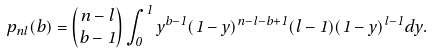Convert formula to latex. <formula><loc_0><loc_0><loc_500><loc_500>p _ { n l } ( b ) = { n - l \choose b - 1 } \int _ { 0 } ^ { 1 } y ^ { b - 1 } ( 1 - y ) ^ { n - l - b + 1 } ( l - 1 ) ( 1 - y ) ^ { l - 1 } d y .</formula> 